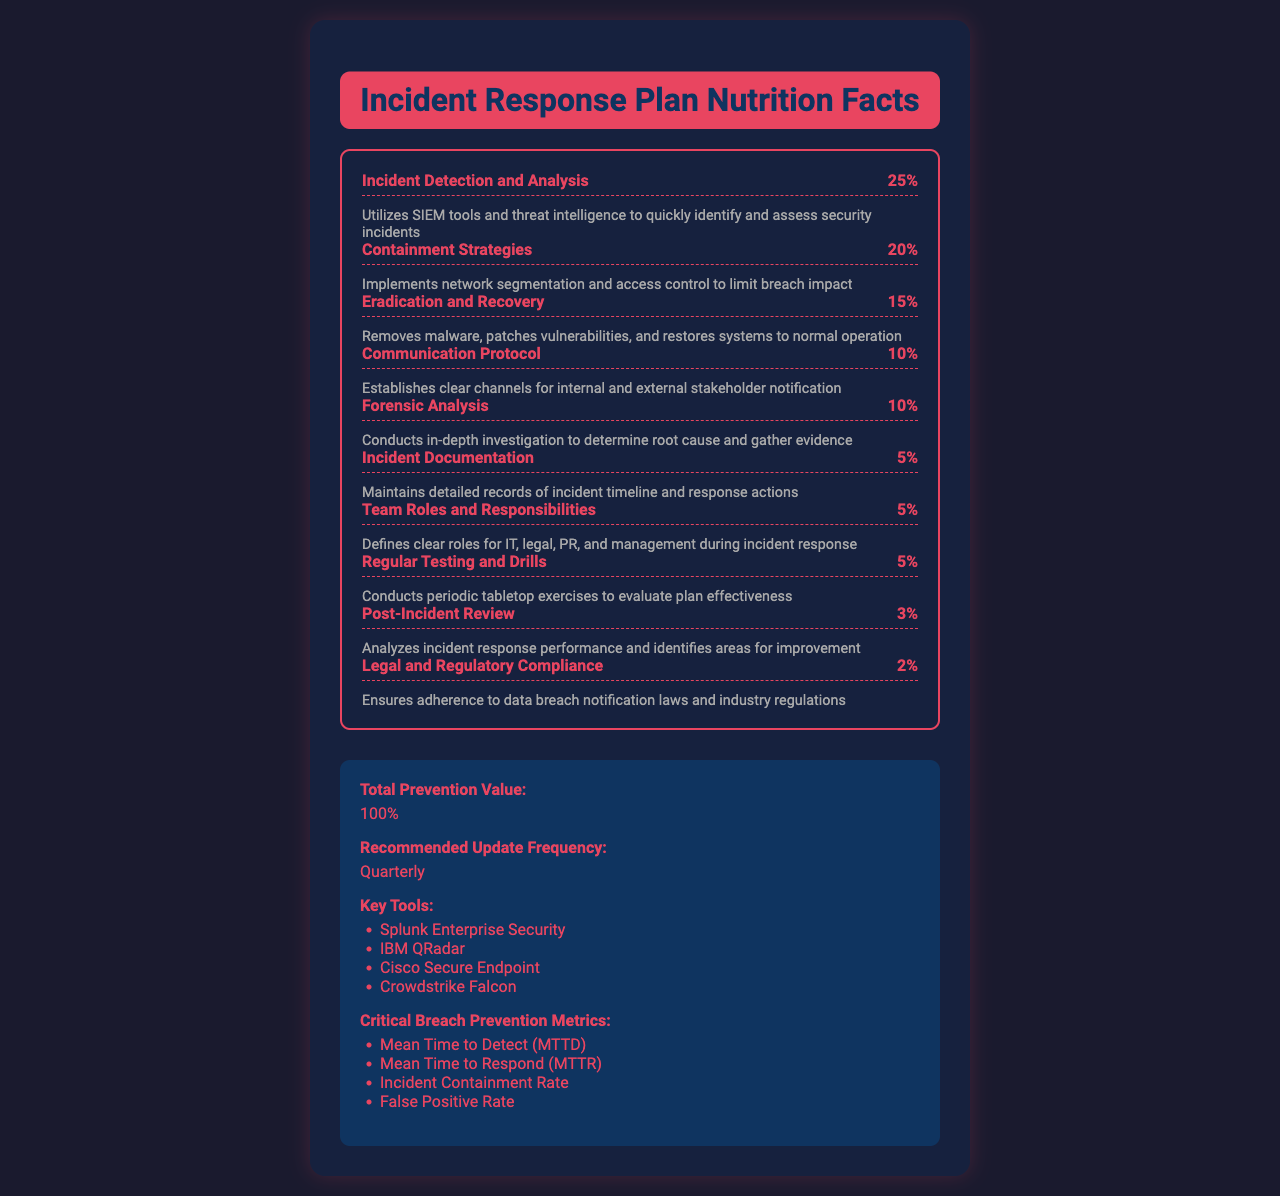What is the percentage importance of the 'Incident Detection and Analysis' component? The document shows that 'Incident Detection and Analysis' has a 25% importance in breach prevention, as listed directly in the component breakdown.
Answer: 25% What strategies are used in the 'Containment Strategies' component? The description for 'Containment Strategies' mentions the use of network segmentation and access control to limit breach impact.
Answer: Network segmentation and access control How often is the Incident Response Plan recommended to be updated? The additional information section specifies that the recommended update frequency is quarterly.
Answer: Quarterly What tools are listed under the key tools for breach prevention? The key tools listed in the additional information section include Splunk Enterprise Security, IBM QRadar, Cisco Secure Endpoint, and Crowdstrike Falcon.
Answer: Splunk Enterprise Security, IBM QRadar, Cisco Secure Endpoint, Crowdstrike Falcon What is the least emphasized component in the Incident Response Plan according to the percentages? According to the listed percentages, 'Legal and Regulatory Compliance' has the lowest percentage at 2%.
Answer: Legal and Regulatory Compliance What critical metric assesses the speed of identifying a security incident? The document lists 'Mean Time to Detect (MTTD)' as a critical metric for breach prevention.
Answer: Mean Time to Detect (MTTD) Which of the following components is focused on identifying and gathering evidence? A. Containment Strategies B. Forensic Analysis C. Communication Protocol D. Incident Documentation The document specifies that 'Forensic Analysis' is the component that conducts in-depth investigations to determine root cause and gather evidence.
Answer: B How much weight does the 'Incident Documentation' component carry in the breach prevention? A. 5% B. 10% C. 15% D. 20% The document assigns 5% importance to the 'Incident Documentation' component.
Answer: A Does 'Regular Testing and Drills' have a higher percentage than 'Forensic Analysis'? 'Regular Testing and Drills' has a 5% importance, while 'Forensic Analysis' has a 10% importance in the breach prevention plan.
Answer: No Summarize the main idea of the Incident Response Plan Nutrition Facts document. The document aims to present the components of an Incident Response Plan comprehensively, showing the relative importance of each aspect to breach prevention. It includes supplementary information about update recommendations, critical metrics, and useful tools.
Answer: The document provides a breakdown of the key components of an Incident Response Plan, detailing each component's importance in breach prevention along with additional information on recommended update frequency, key tools, and critical metrics. What specific SIEM tools are recommended for 'Incident Detection and Analysis'? The document lists components and functionalities but does not specify the exact SIEM tools recommended for 'Incident Detection and Analysis'.
Answer: Cannot be determined 